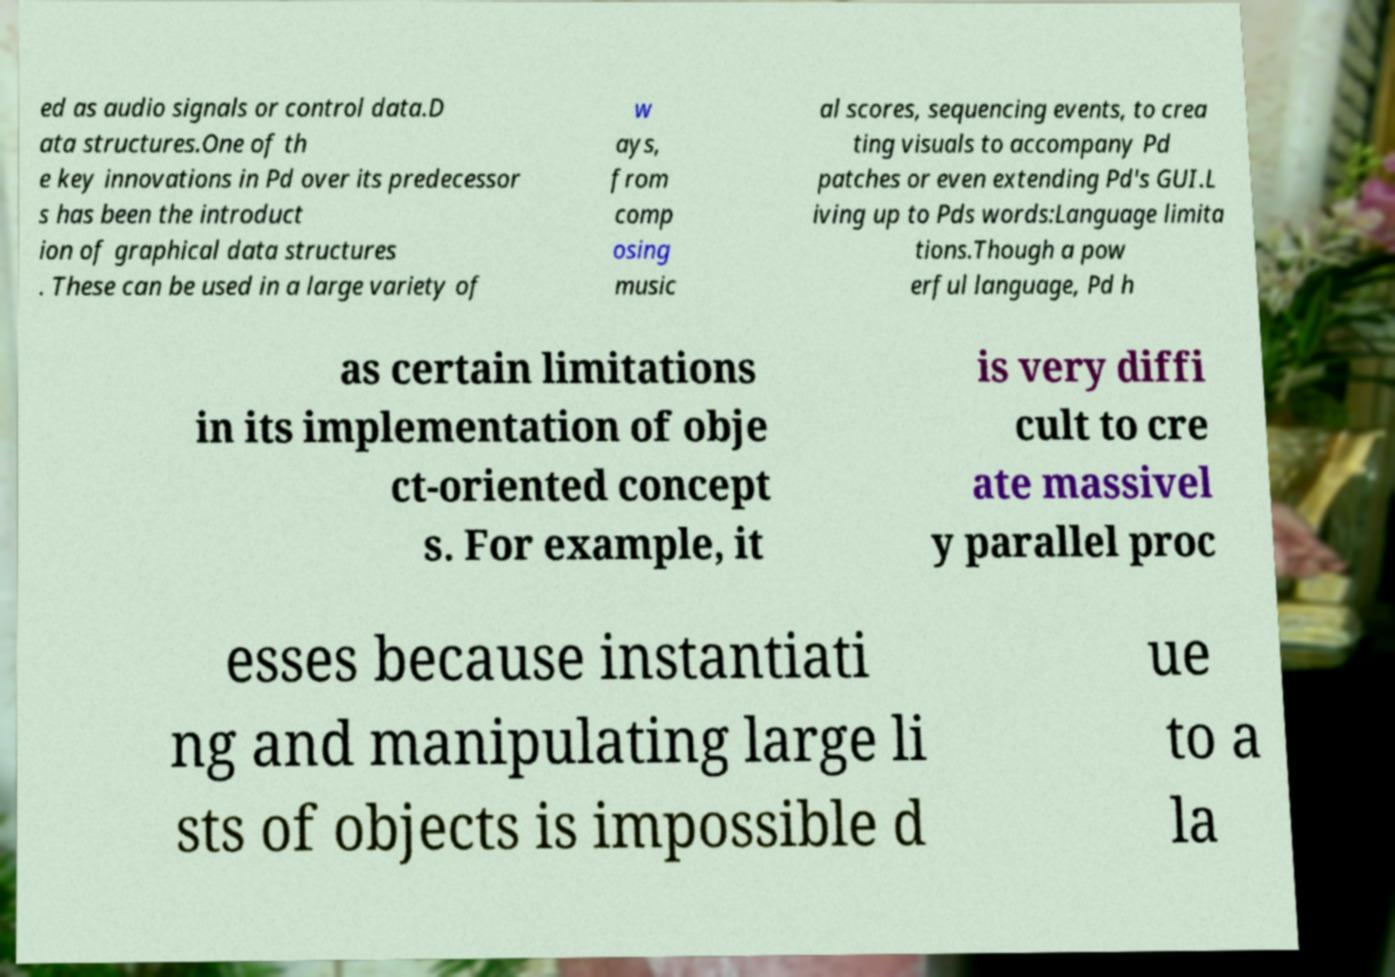Could you extract and type out the text from this image? ed as audio signals or control data.D ata structures.One of th e key innovations in Pd over its predecessor s has been the introduct ion of graphical data structures . These can be used in a large variety of w ays, from comp osing music al scores, sequencing events, to crea ting visuals to accompany Pd patches or even extending Pd's GUI.L iving up to Pds words:Language limita tions.Though a pow erful language, Pd h as certain limitations in its implementation of obje ct-oriented concept s. For example, it is very diffi cult to cre ate massivel y parallel proc esses because instantiati ng and manipulating large li sts of objects is impossible d ue to a la 